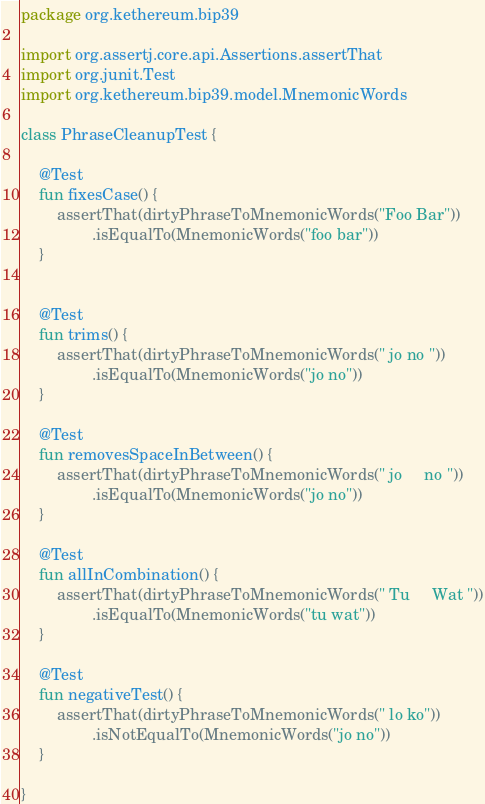<code> <loc_0><loc_0><loc_500><loc_500><_Kotlin_>package org.kethereum.bip39

import org.assertj.core.api.Assertions.assertThat
import org.junit.Test
import org.kethereum.bip39.model.MnemonicWords

class PhraseCleanupTest {

    @Test
    fun fixesCase() {
        assertThat(dirtyPhraseToMnemonicWords("Foo Bar"))
                .isEqualTo(MnemonicWords("foo bar"))
    }


    @Test
    fun trims() {
        assertThat(dirtyPhraseToMnemonicWords(" jo no "))
                .isEqualTo(MnemonicWords("jo no"))
    }

    @Test
    fun removesSpaceInBetween() {
        assertThat(dirtyPhraseToMnemonicWords(" jo     no "))
                .isEqualTo(MnemonicWords("jo no"))
    }

    @Test
    fun allInCombination() {
        assertThat(dirtyPhraseToMnemonicWords(" Tu     Wat "))
                .isEqualTo(MnemonicWords("tu wat"))
    }

    @Test
    fun negativeTest() {
        assertThat(dirtyPhraseToMnemonicWords(" lo ko"))
                .isNotEqualTo(MnemonicWords("jo no"))
    }

}</code> 